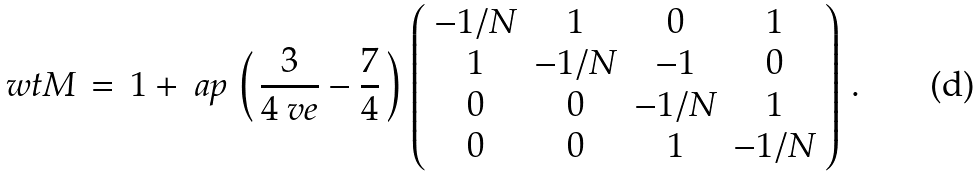<formula> <loc_0><loc_0><loc_500><loc_500>\ w t M \, = \, 1 + \ a p \, \left ( \, \frac { 3 } { 4 \ v e } - \frac { 7 } { 4 } \, \right ) \, \left ( \begin{array} { c c c c } - 1 / N & 1 & 0 & 1 \\ 1 & - 1 / N & - 1 & 0 \\ 0 & 0 & - 1 / N & 1 \\ 0 & 0 & 1 & - 1 / N \end{array} \right ) \, .</formula> 